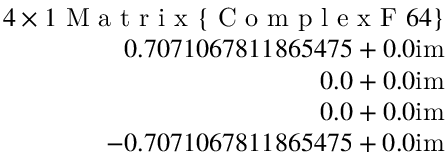<formula> <loc_0><loc_0><loc_500><loc_500>\begin{array} { r } { 4 \times 1 M a t r i x \{ C o m p l e x F 6 4 \} } \\ { 0 . 7 0 7 1 0 6 7 8 1 1 8 6 5 4 7 5 + 0 . 0 i m } \\ { 0 . 0 + 0 . 0 i m } \\ { 0 . 0 + 0 . 0 i m } \\ { - 0 . 7 0 7 1 0 6 7 8 1 1 8 6 5 4 7 5 + 0 . 0 i m } \end{array}</formula> 